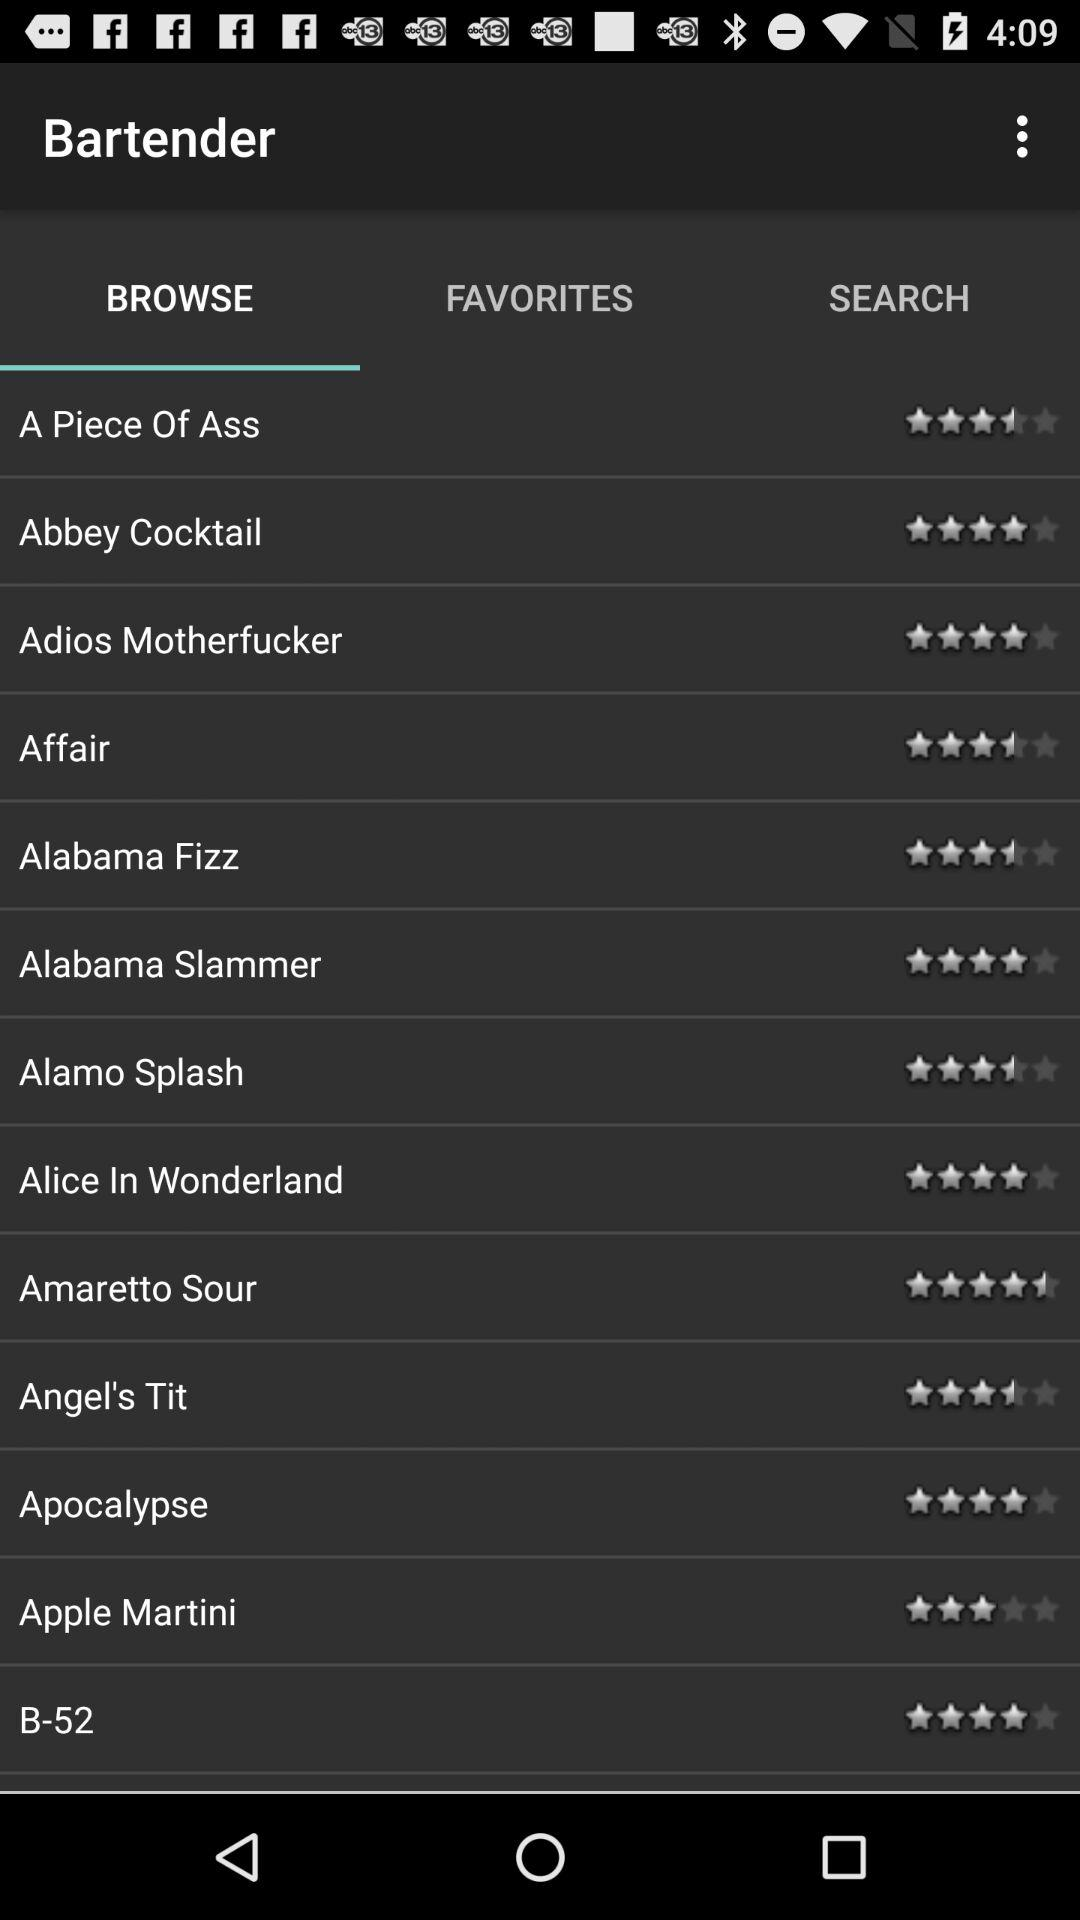Which items are in "FAVORITES"?
When the provided information is insufficient, respond with <no answer>. <no answer> 